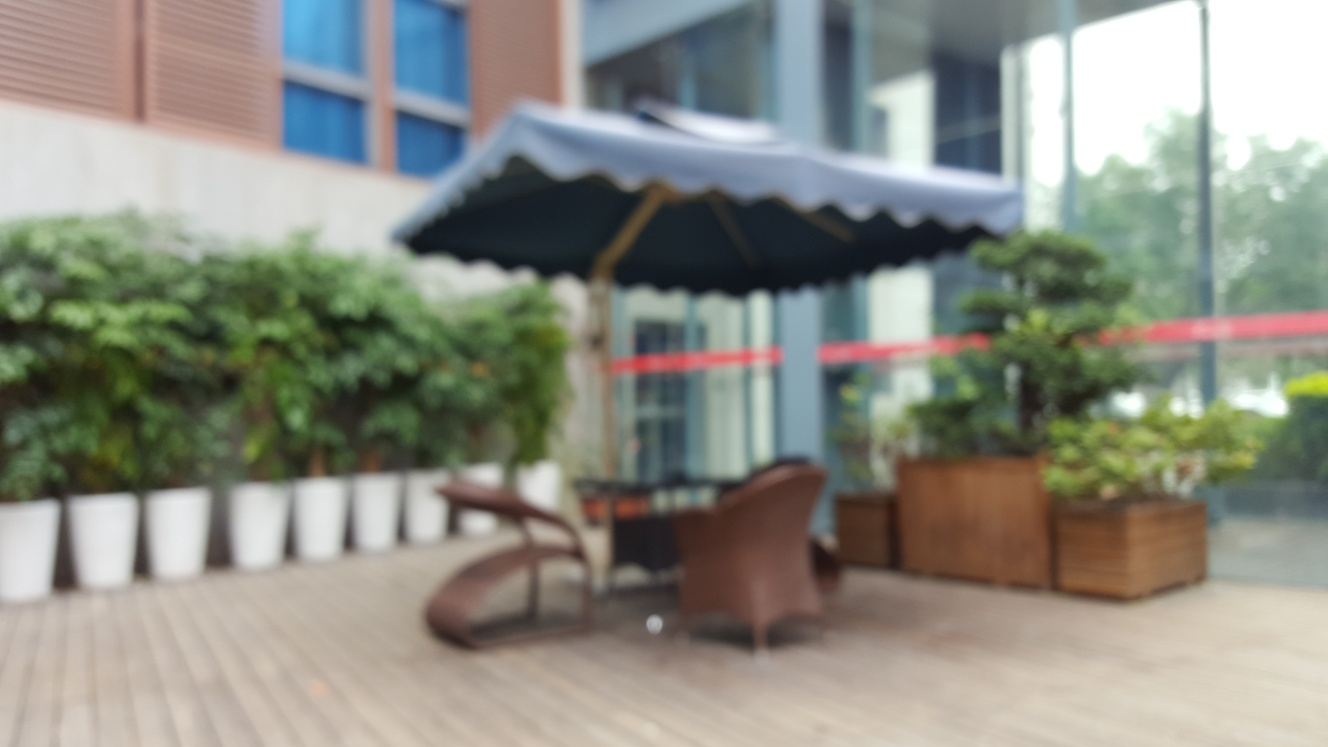What time of day does this scene look like? The lighting in the image suggests it may be taken during the daytime, although the exact time cannot be determined with certainty due to the image being out of focus. There's a general brightness that indicates daylight. 